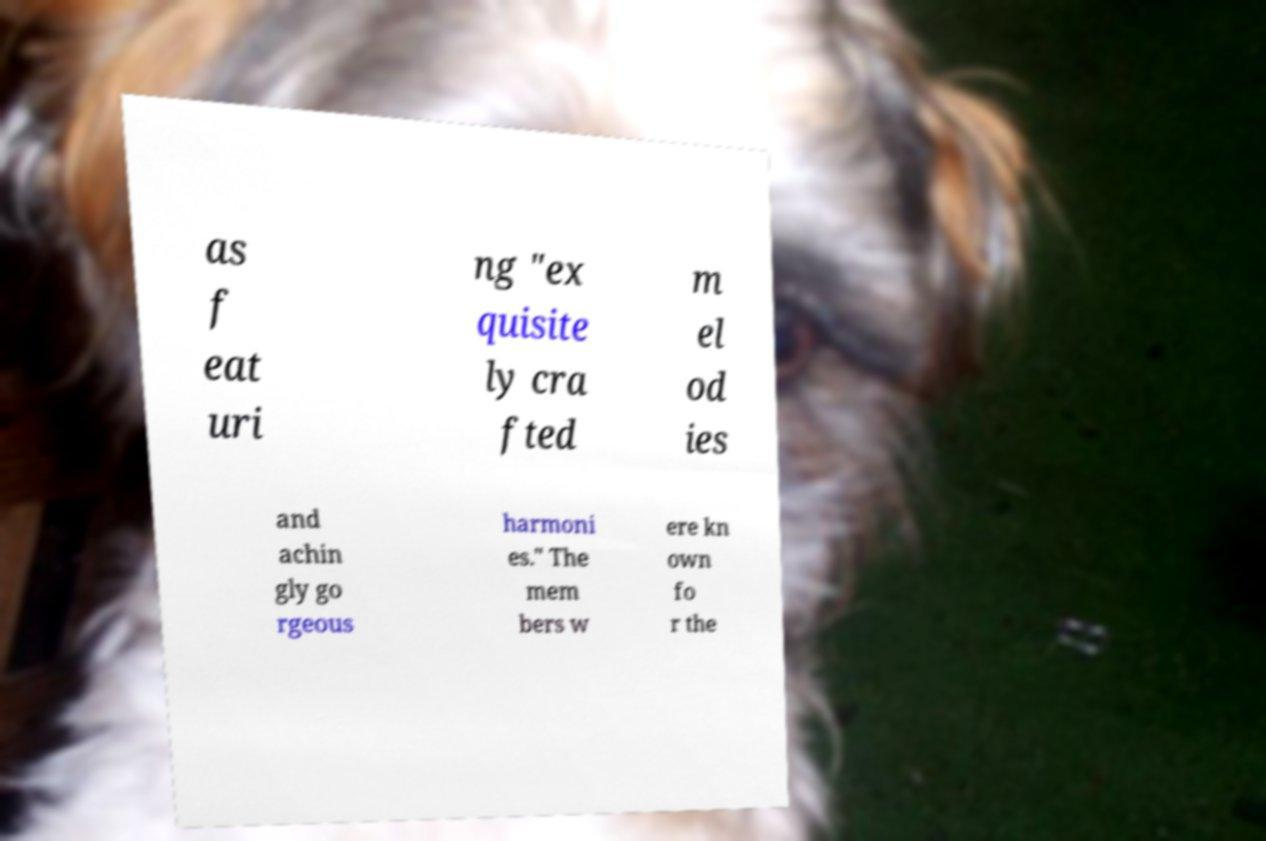Could you assist in decoding the text presented in this image and type it out clearly? as f eat uri ng "ex quisite ly cra fted m el od ies and achin gly go rgeous harmoni es." The mem bers w ere kn own fo r the 